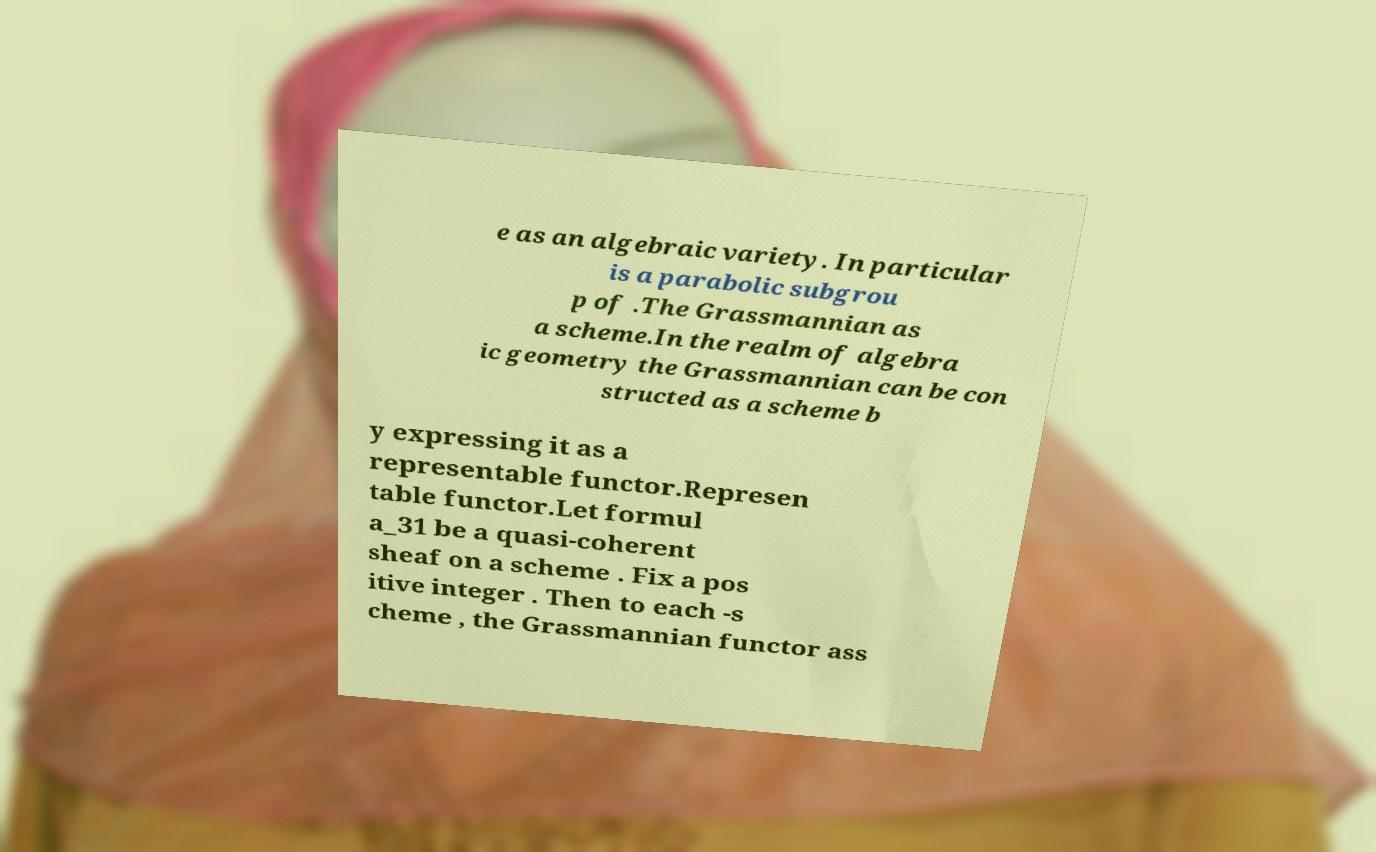Please identify and transcribe the text found in this image. e as an algebraic variety. In particular is a parabolic subgrou p of .The Grassmannian as a scheme.In the realm of algebra ic geometry the Grassmannian can be con structed as a scheme b y expressing it as a representable functor.Represen table functor.Let formul a_31 be a quasi-coherent sheaf on a scheme . Fix a pos itive integer . Then to each -s cheme , the Grassmannian functor ass 